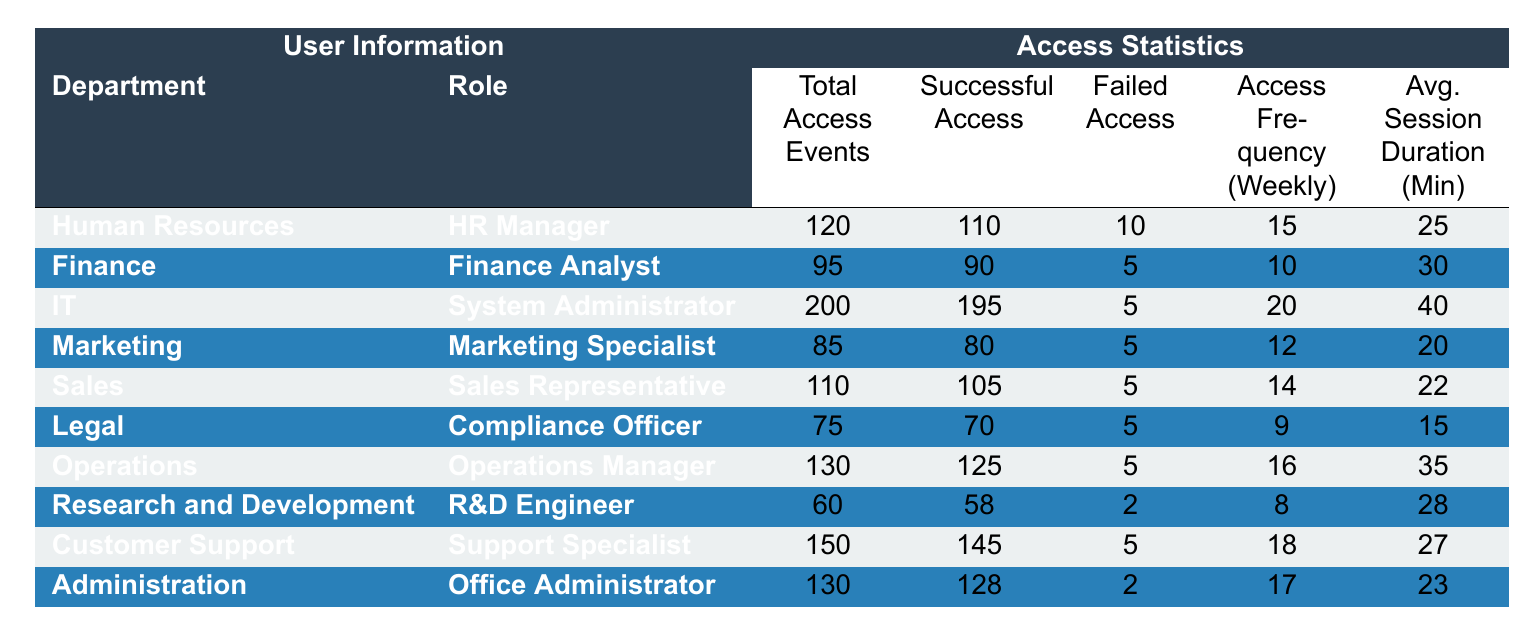What is the total number of access events for the IT department? The IT department has a total of 200 access events listed in the "Total Access Events" column.
Answer: 200 Which role has the highest number of successful access events? The role of System Administrator in the IT department has the highest successful access events, totaling 195.
Answer: System Administrator How many departments have access frequencies greater than 15 per week? The departments with access frequency greater than 15 are IT (20), Operations (16), and Customer Support (18), which totals 3 departments.
Answer: 3 What is the average session duration for the Marketing department? The Marketing department has an average session duration of 20 minutes, as seen in the respective column.
Answer: 20 Is the number of failed access events in the Sales department less than 10? The Sales department has 5 failed access events, which is less than 10.
Answer: Yes What is the total number of successful access events across all departments? To find the total successful access events, sum all successful accesses: 110 + 90 + 195 + 80 + 105 + 70 + 125 + 58 + 145 + 128 = 1,100.
Answer: 1,100 Which department has the lowest average session duration? The Legal department has the lowest average session duration, which is 15 minutes.
Answer: Legal If we consider only departments with a failed access count of 5, how many access events do they have in total? The departments with 5 failed accesses are Human Resources (120), Finance (95), IT (200), Marketing (85), Sales (110), and Customer Support (150). Total these: 120 + 95 + 200 + 85 + 110 + 150 = 860.
Answer: 860 What is the difference in total access events between the highest and lowest departments? The highest total access events is in IT (200) and the lowest is in Research and Development (60). The difference is 200 - 60 = 140.
Answer: 140 What role has the highest average session duration? The System Administrator role in IT has the highest average session duration of 40 minutes.
Answer: System Administrator How many departments have a higher successful access ratio than 90%? To find the ratio, calculate for each department: HR (110/120=91.67%), Finance (90/95=94.74%), IT (195/200=97.5%), Marketing (80/85=94.12%), Sales (105/110=95.45%), Legal (70/75=93.33%), Operations (125/130=96.15%), R&D (58/60=96.67%), Customer Support (145/150=96.67%), and Administration (128/130=98.46%). All departments except R&D and Legal have ratios greater than 90%, totaling 8 departments.
Answer: 8 What is the average access frequency across all departments? To find the average access frequency, sum them up (15 + 10 + 20 + 12 + 14 + 9 + 16 + 8 + 18 + 17 = 149) and divide by the number of departments (10), giving an average of 14.9.
Answer: 14.9 